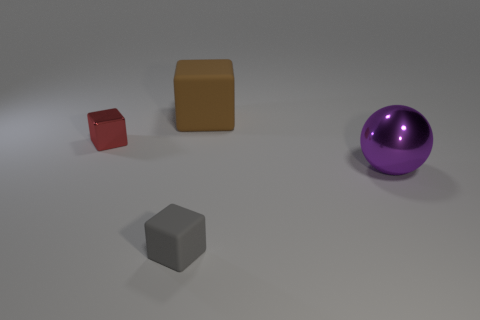There is a tiny object in front of the metal thing that is to the right of the brown matte object; what is its color?
Provide a succinct answer. Gray. Does the purple sphere have the same material as the tiny block behind the large purple shiny thing?
Provide a short and direct response. Yes. There is a purple ball right of the large matte block; what is it made of?
Provide a short and direct response. Metal. Are there the same number of large brown cubes to the right of the big metal thing and matte cubes?
Make the answer very short. No. Is there any other thing that has the same size as the shiny block?
Keep it short and to the point. Yes. There is a large thing that is right of the large thing that is to the left of the large purple thing; what is its material?
Make the answer very short. Metal. What shape is the object that is both in front of the brown rubber thing and behind the ball?
Offer a terse response. Cube. The red thing that is the same shape as the big brown matte thing is what size?
Give a very brief answer. Small. Is the number of purple metal spheres that are behind the big brown rubber cube less than the number of matte balls?
Your answer should be compact. No. How big is the metallic object to the left of the big purple ball?
Your answer should be very brief. Small. 